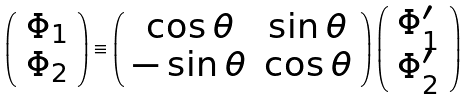Convert formula to latex. <formula><loc_0><loc_0><loc_500><loc_500>\left ( \begin{array} { c } { { \Phi _ { 1 } } } \\ { { \Phi _ { 2 } } } \end{array} \right ) \equiv \left ( \begin{array} { c c } { \cos \theta } & { \sin \theta } \\ { - \sin \theta } & { \cos \theta } \end{array} \right ) \left ( \begin{array} { c } { { \Phi _ { 1 } ^ { \prime } } } \\ { { \Phi _ { 2 } ^ { \prime } } } \end{array} \right )</formula> 